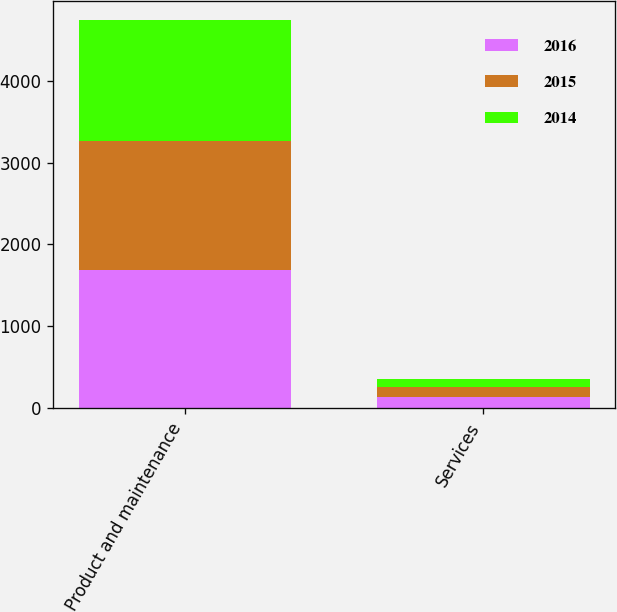Convert chart. <chart><loc_0><loc_0><loc_500><loc_500><stacked_bar_chart><ecel><fcel>Product and maintenance<fcel>Services<nl><fcel>2016<fcel>1683.8<fcel>132.3<nl><fcel>2015<fcel>1578.9<fcel>123.2<nl><fcel>2014<fcel>1479.2<fcel>101.8<nl></chart> 